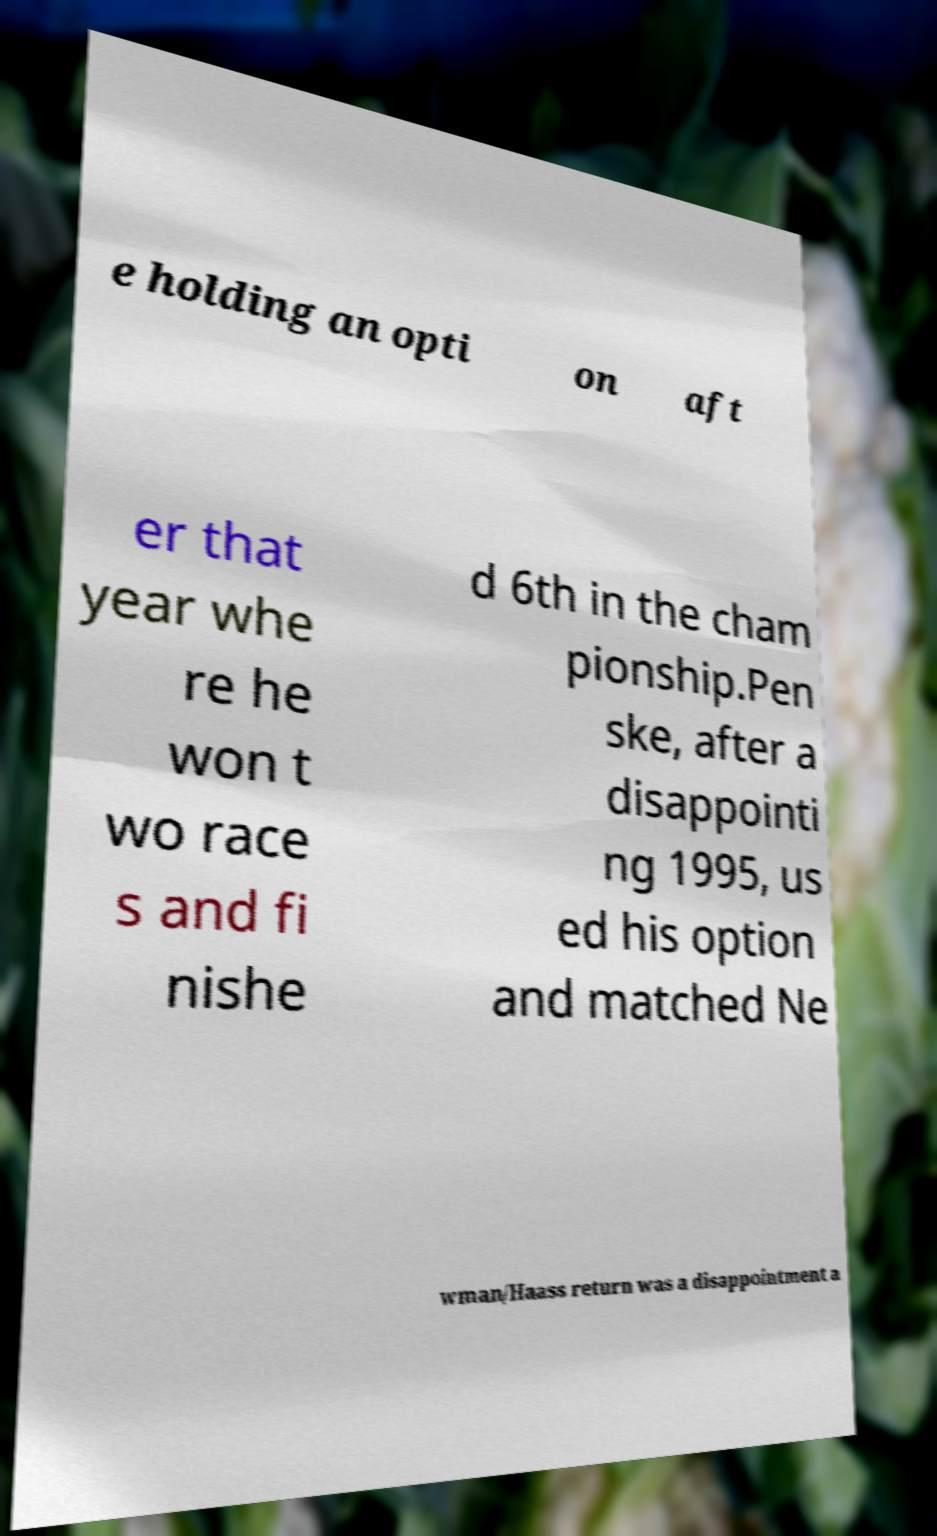There's text embedded in this image that I need extracted. Can you transcribe it verbatim? e holding an opti on aft er that year whe re he won t wo race s and fi nishe d 6th in the cham pionship.Pen ske, after a disappointi ng 1995, us ed his option and matched Ne wman/Haass return was a disappointment a 